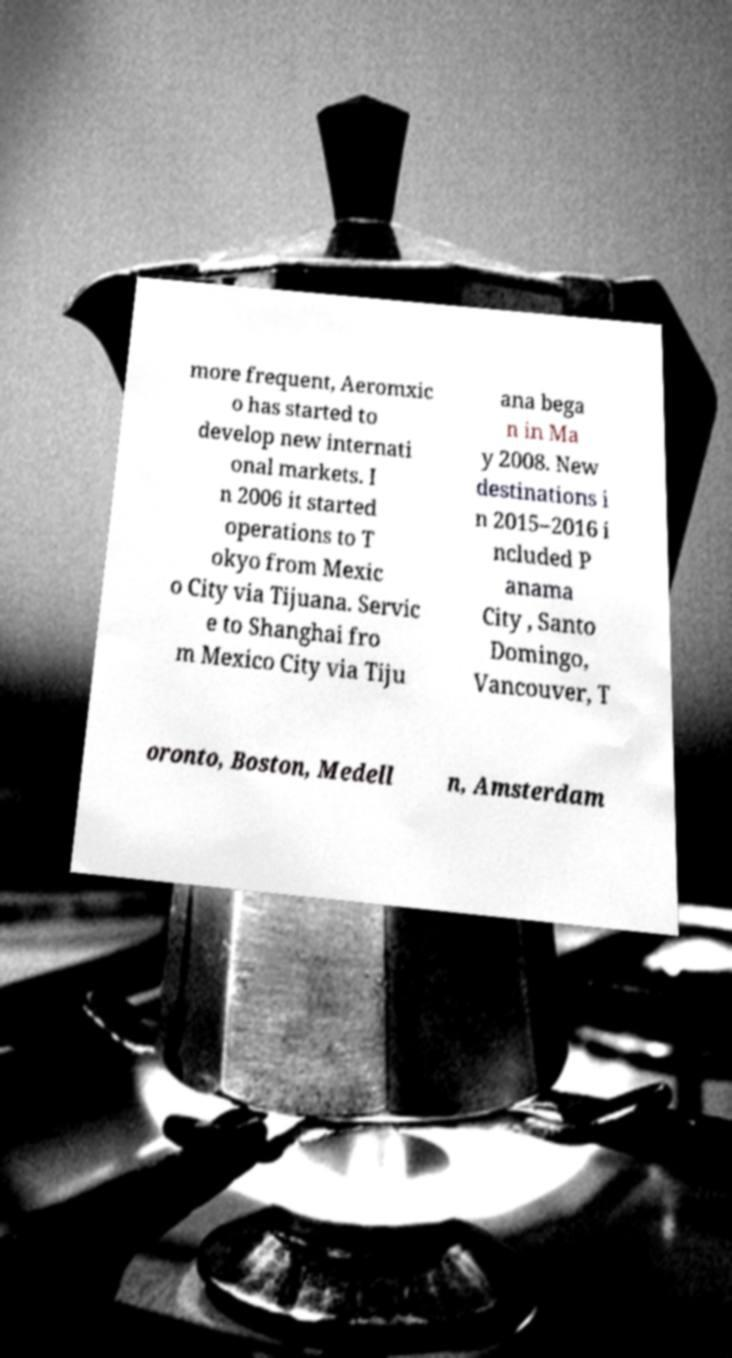Please read and relay the text visible in this image. What does it say? more frequent, Aeromxic o has started to develop new internati onal markets. I n 2006 it started operations to T okyo from Mexic o City via Tijuana. Servic e to Shanghai fro m Mexico City via Tiju ana bega n in Ma y 2008. New destinations i n 2015–2016 i ncluded P anama City , Santo Domingo, Vancouver, T oronto, Boston, Medell n, Amsterdam 